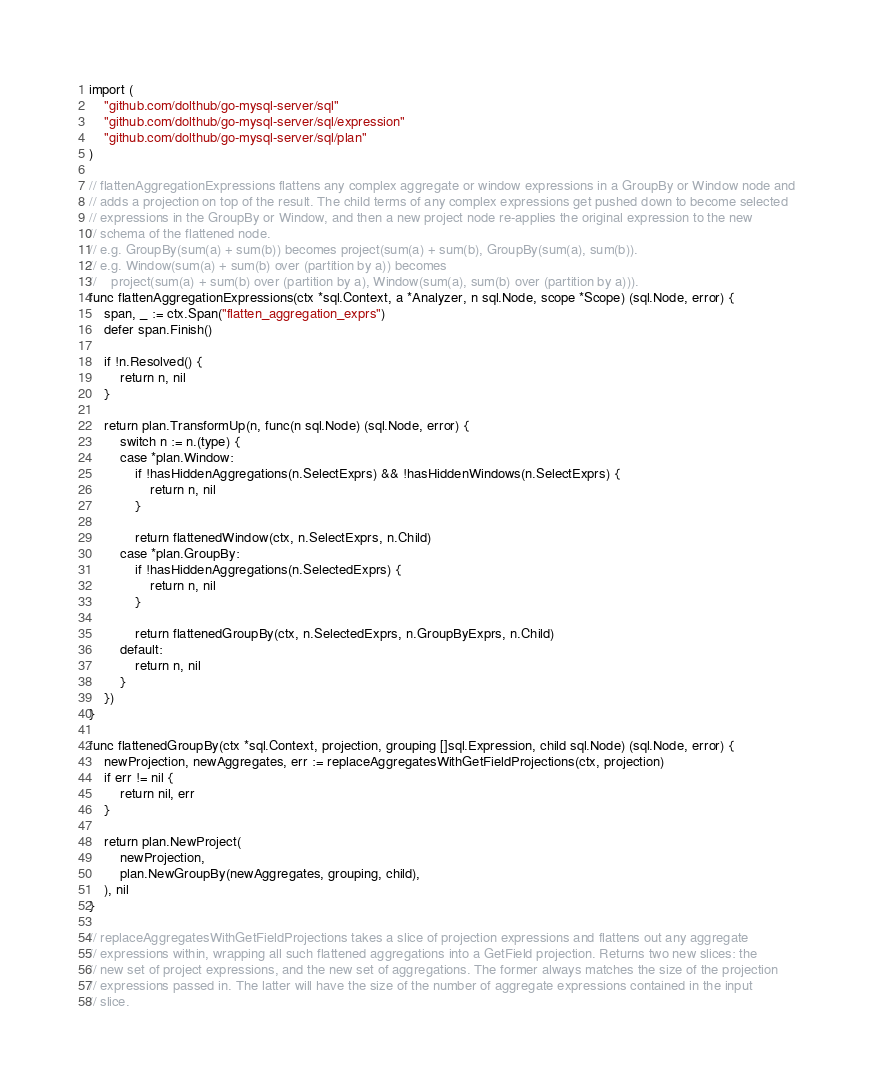<code> <loc_0><loc_0><loc_500><loc_500><_Go_>
import (
	"github.com/dolthub/go-mysql-server/sql"
	"github.com/dolthub/go-mysql-server/sql/expression"
	"github.com/dolthub/go-mysql-server/sql/plan"
)

// flattenAggregationExpressions flattens any complex aggregate or window expressions in a GroupBy or Window node and
// adds a projection on top of the result. The child terms of any complex expressions get pushed down to become selected
// expressions in the GroupBy or Window, and then a new project node re-applies the original expression to the new
// schema of the flattened node.
// e.g. GroupBy(sum(a) + sum(b)) becomes project(sum(a) + sum(b), GroupBy(sum(a), sum(b)).
// e.g. Window(sum(a) + sum(b) over (partition by a)) becomes
//    project(sum(a) + sum(b) over (partition by a), Window(sum(a), sum(b) over (partition by a))).
func flattenAggregationExpressions(ctx *sql.Context, a *Analyzer, n sql.Node, scope *Scope) (sql.Node, error) {
	span, _ := ctx.Span("flatten_aggregation_exprs")
	defer span.Finish()

	if !n.Resolved() {
		return n, nil
	}

	return plan.TransformUp(n, func(n sql.Node) (sql.Node, error) {
		switch n := n.(type) {
		case *plan.Window:
			if !hasHiddenAggregations(n.SelectExprs) && !hasHiddenWindows(n.SelectExprs) {
				return n, nil
			}

			return flattenedWindow(ctx, n.SelectExprs, n.Child)
		case *plan.GroupBy:
			if !hasHiddenAggregations(n.SelectedExprs) {
				return n, nil
			}

			return flattenedGroupBy(ctx, n.SelectedExprs, n.GroupByExprs, n.Child)
		default:
			return n, nil
		}
	})
}

func flattenedGroupBy(ctx *sql.Context, projection, grouping []sql.Expression, child sql.Node) (sql.Node, error) {
	newProjection, newAggregates, err := replaceAggregatesWithGetFieldProjections(ctx, projection)
	if err != nil {
		return nil, err
	}

	return plan.NewProject(
		newProjection,
		plan.NewGroupBy(newAggregates, grouping, child),
	), nil
}

// replaceAggregatesWithGetFieldProjections takes a slice of projection expressions and flattens out any aggregate
// expressions within, wrapping all such flattened aggregations into a GetField projection. Returns two new slices: the
// new set of project expressions, and the new set of aggregations. The former always matches the size of the projection
// expressions passed in. The latter will have the size of the number of aggregate expressions contained in the input
// slice.</code> 